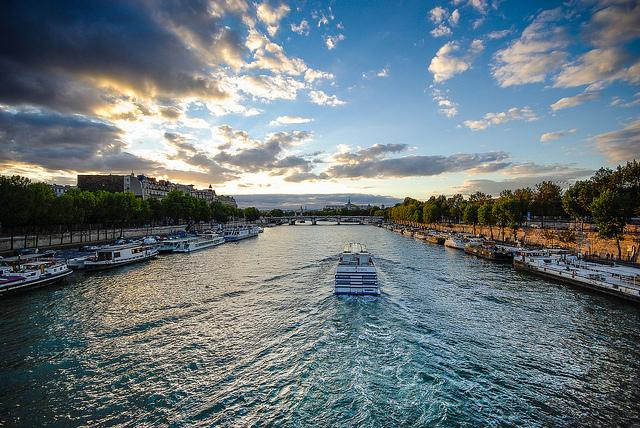What is creating the larger waves? Please explain your reasoning. boat. The boat is creating some larger waves. 